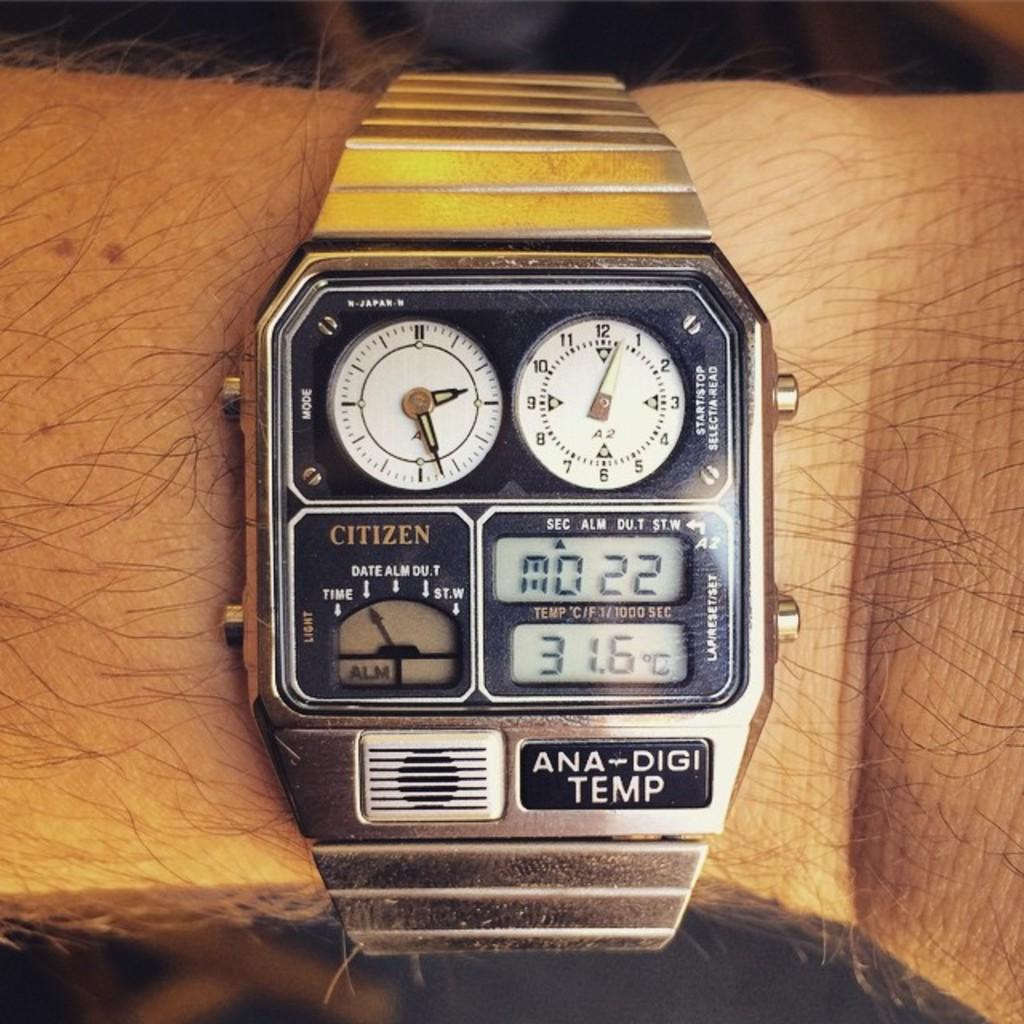<image>
Give a short and clear explanation of the subsequent image. an old citizen watch has several faces on it 